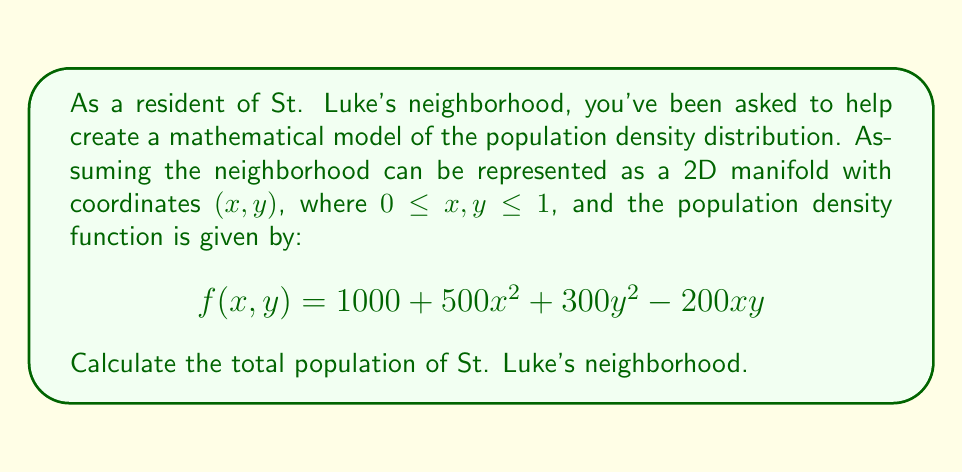Could you help me with this problem? To find the total population of St. Luke's neighborhood, we need to integrate the population density function over the entire 2D manifold. This involves calculating a double integral of the given function $f(x,y)$ over the specified domain.

1) The population density function is:
   $$f(x,y) = 1000 + 500x^2 + 300y^2 - 200xy$$

2) The domain of integration is a square with sides of length 1:
   $0 \leq x \leq 1$ and $0 \leq y \leq 1$

3) We need to calculate the double integral:
   $$\int_0^1 \int_0^1 f(x,y) \, dx \, dy$$

4) Expanding this:
   $$\int_0^1 \int_0^1 (1000 + 500x^2 + 300y^2 - 200xy) \, dx \, dy$$

5) We can integrate each term separately:

   For the constant term: 
   $$\int_0^1 \int_0^1 1000 \, dx \, dy = 1000$$

   For $500x^2$: 
   $$\int_0^1 \int_0^1 500x^2 \, dx \, dy = 500 \cdot \frac{1}{3} = \frac{500}{3}$$

   For $300y^2$: 
   $$\int_0^1 \int_0^1 300y^2 \, dx \, dy = 300 \cdot \frac{1}{3} = 100$$

   For $-200xy$: 
   $$\int_0^1 \int_0^1 -200xy \, dx \, dy = -200 \cdot \frac{1}{4} = -50$$

6) Sum all these terms:
   $$1000 + \frac{500}{3} + 100 - 50 = 1000 + \frac{500}{3} + 50 = 1216.\overline{6}$$

Therefore, the total population of St. Luke's neighborhood is approximately 1216.67 people.
Answer: The total population of St. Luke's neighborhood is $1216.\overline{6}$ or approximately 1216.67 people. 